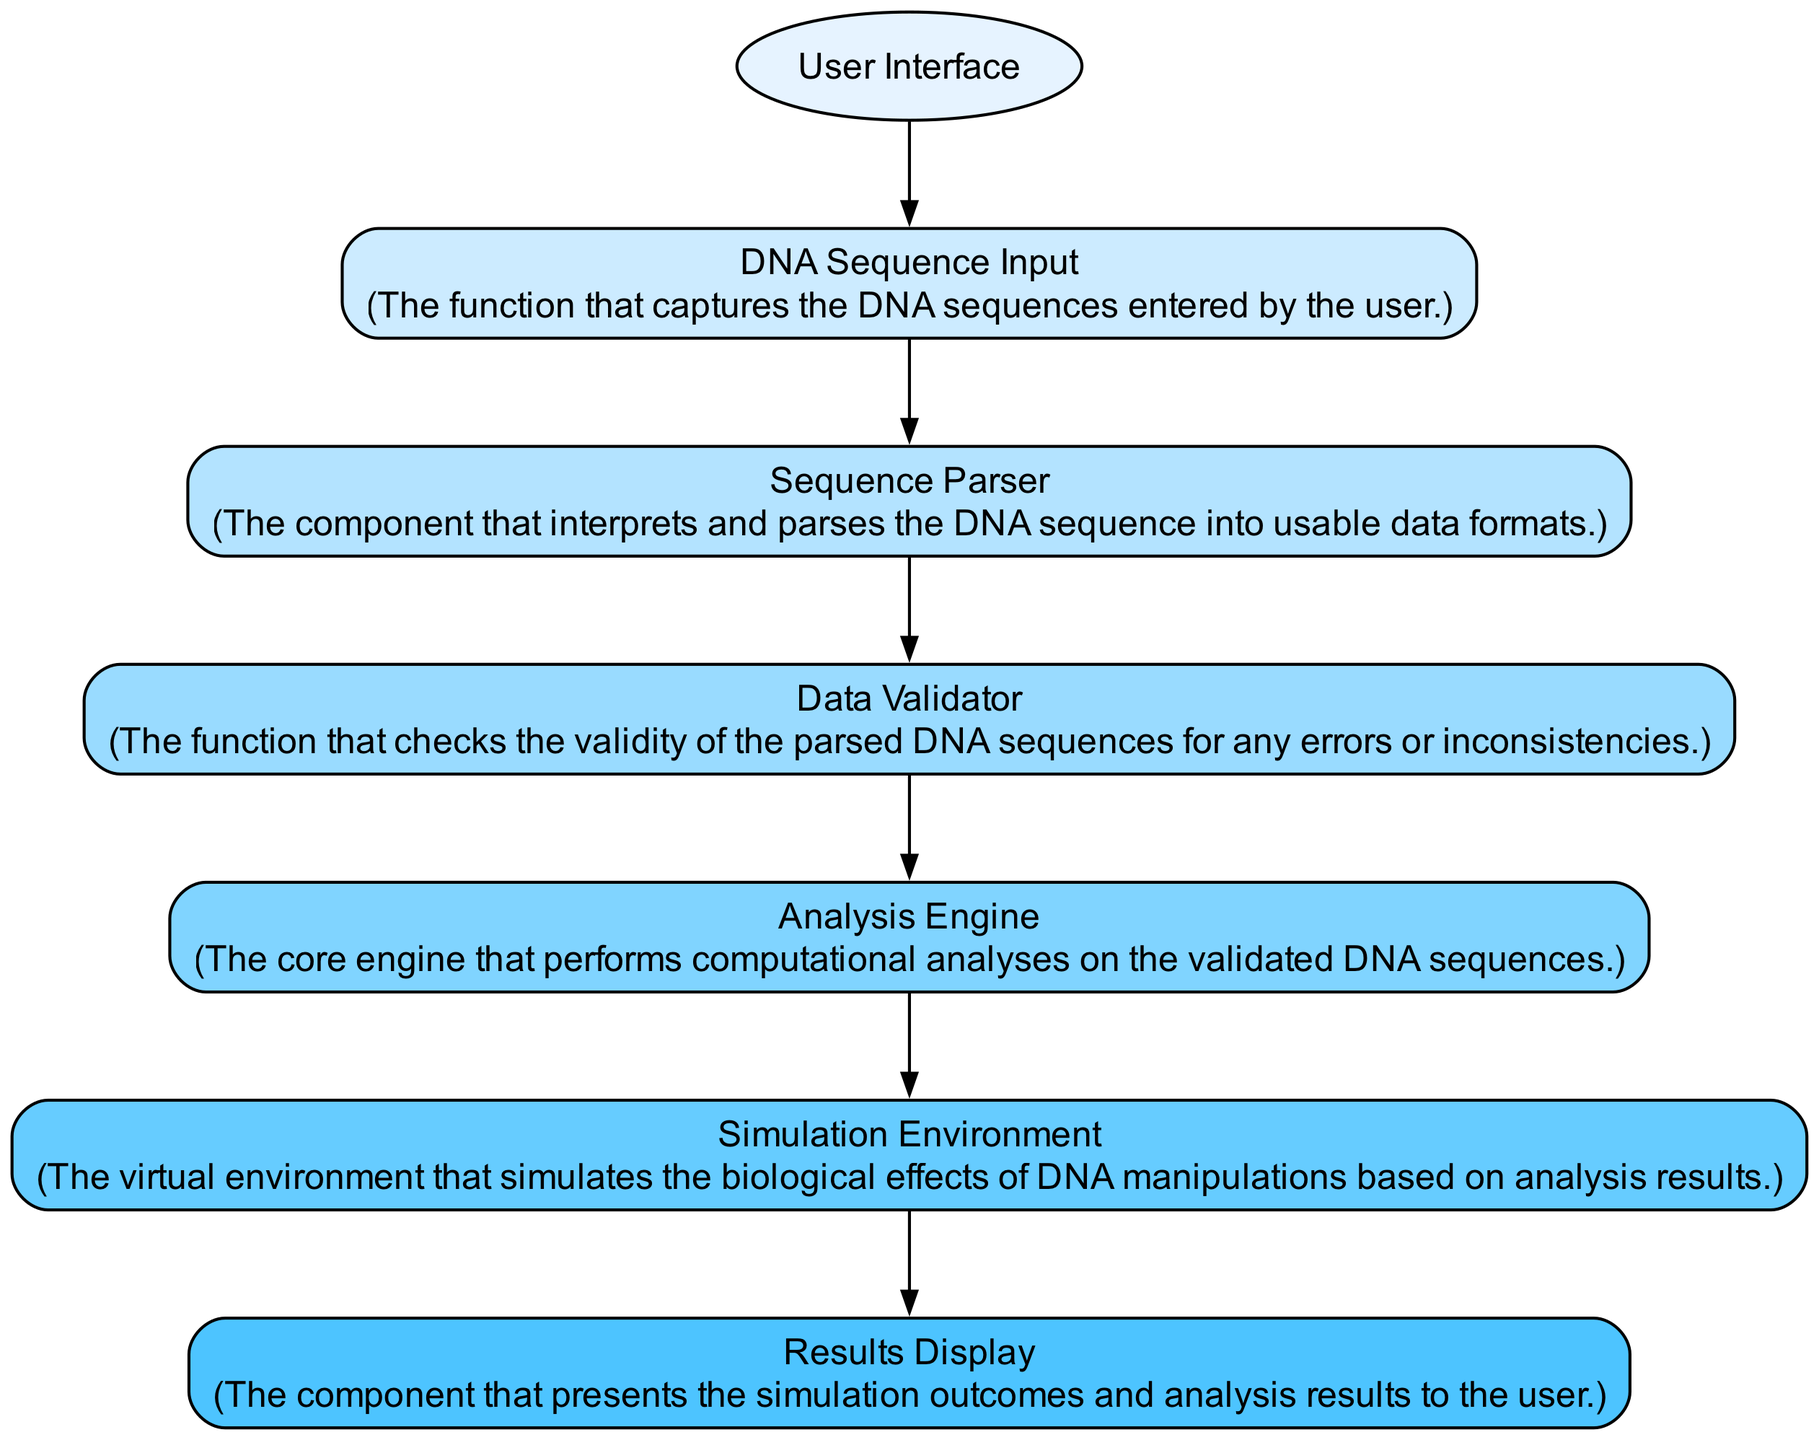What is the first component in the sequence? The first component in the sequence is the "User Interface," where the user inputs DNA sequences for analysis. It is the initial point in the workflow diagram.
Answer: User Interface How many processes are involved in the workflow? The workflow includes six processes: DNA Sequence Input, Sequence Parser, Data Validator, Analysis Engine, Simulation Environment, and Results Display. This is identified by counting all the process nodes in the diagram.
Answer: Six What component follows the "Data Validator"? The component that follows "Data Validator" is "Analysis Engine." This is determined by the directed connection from the Data Validator to the Analysis Engine in the diagram.
Answer: Analysis Engine Which component is responsible for presenting simulation outcomes? The "Results Display" component is responsible for presenting the simulation outcomes and analysis results to the user. This can be directly found within the description of that process node in the diagram.
Answer: Results Display What is the relationship between "Sequence Parser" and "Data Validator"? The relationship is sequential; the "Sequence Parser" passes its output to the "Data Validator" for checking the validity of the parsed DNA sequences. This is understood through the directed edge connecting these two nodes in the workflow.
Answer: Sequential How does the input flow from the user to the simulation? The input flows from the "User Interface" to "DNA Sequence Input," then to "Sequence Parser," followed by "Data Validator," next to "Analysis Engine," then to "Simulation Environment," which indicates that each component processes the output of the previous one, leading to the simulation.
Answer: Through multiple processes How many edges are there in total? There are five edges in total connecting the six nodes, as each node (except the last one) connects to the next with a single directional edge. This is counted by observing the connections between nodes in the diagram.
Answer: Five Which component acts as the intermediate step before simulation? The "Analysis Engine" acts as the intermediate step before the "Simulation Environment." This is identified by the flow of connections in the sequence diagram where the Analysis Engine leads into the Simulation Environment.
Answer: Analysis Engine What is the last component in the sequence? The last component in the sequence is "Results Display," which provides the output of the workflow to the user, marking the end of the analysis process. This is found by observing the final node in the correct flow of the diagram.
Answer: Results Display 